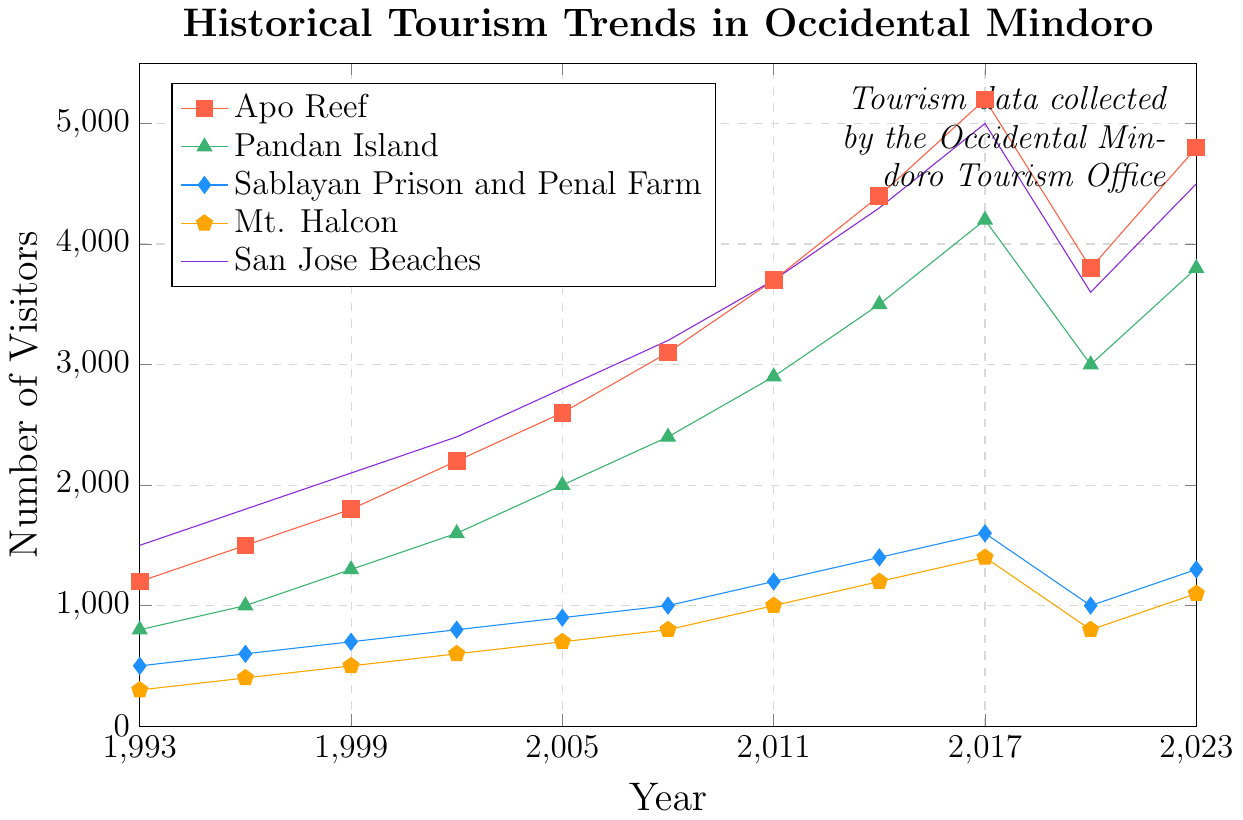Which attraction had the highest number of visitors in 2023? To find the attraction with the highest number of visitors in 2023, look at the visitor counts for each attraction in that year. San Jose Beaches had 4500 visitors, which is the highest among all attractions.
Answer: San Jose Beaches What was the difference in visitor numbers between Apo Reef and Pandan Island in 2017? In 2017, Apo Reef had 5200 visitors and Pandan Island had 4200 visitors. Subtracting the visitor numbers for Pandan Island from Apo Reef gives 5200 - 4200 = 1000.
Answer: 1000 Did any attraction see a decline in visitors between 2017 and 2020? By comparing the visitor numbers for each attraction between 2017 and 2020, both Apo Reef and Pandan Island saw declines in visitors: Apo Reef declined from 5200 to 3800 and Pandan Island declined from 4200 to 3000.
Answer: Yes What was the average number of visitors to Mt. Halcon across all recorded years? Sum the visitors to Mt. Halcon for all years: 300 + 400 + 500 + 600 + 700 + 800 + 1000 + 1200 + 1400 + 800 + 1100 = 8800. Divide by the number of years (11): 8800 / 11 = 800.
Answer: 800 Which year had the maximum difference in visitor numbers between Sablayan Prison and Penal Farm and Mt. Halcon? By calculating the differences year by year: 
1993: 500 - 300 = 200
1996: 600 - 400 = 200
1999: 700 - 500 = 200
2002: 800 - 600 = 200
2005: 900 - 700 = 200
2008: 1000 - 800 = 200
2011: 1200 - 1000 = 200
2014: 1400 - 1200 = 200
2017: 1600 - 1400 = 200
2020: 1000 - 800 = 200
2023: 1300 - 1100 = 200
No year had a difference greater than 200, so the maximum was consistently 200 across all years.
Answer: 200 (multiple years) Which attraction consistently saw an increase in visitor numbers every recorded year until 2017? From the visitor data, both Apo Reef and San Jose Beaches saw consistent increases in visitor numbers from 1993 to 2017.
Answer: Apo Reef and San Jose Beaches By how much did the visitor numbers to San Jose Beaches decline from 2017 to 2020? In 2017, San Jose Beaches had 5000 visitors, and in 2020 it had 3600 visitors. The decline is 5000 - 3600 = 1400.
Answer: 1400 Which attraction experienced the largest growth in visitor numbers from 1993 to 2023? Calculate the growth for each attraction:
Apo Reef: 4800 - 1200 = 3600
Pandan Island: 3800 - 800 = 3000
Sablayan: 1300 - 500 = 800
Mt. Halcon: 1100 - 300 = 800
San Jose Beaches: 4500 - 1500 = 3000
The largest growth was in Apo Reef with 3600.
Answer: Apo Reef What is the sum of visitors to Pandan Island for all recorded years? Sum the visitors to Pandan Island for all years: 800 + 1000 + 1300 + 1600 + 2000 + 2400 + 2900 + 3500 + 4200 + 3000 + 3800 = 26500.
Answer: 26500 